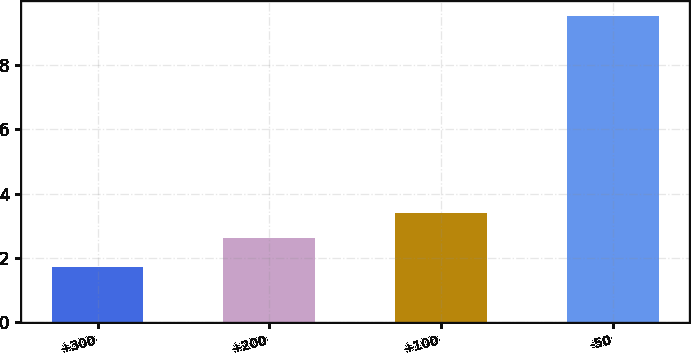Convert chart to OTSL. <chart><loc_0><loc_0><loc_500><loc_500><bar_chart><fcel>+300<fcel>+200<fcel>+100<fcel>-50<nl><fcel>1.72<fcel>2.61<fcel>3.39<fcel>9.52<nl></chart> 